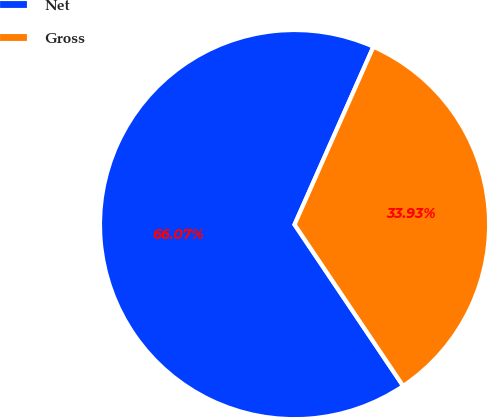Convert chart. <chart><loc_0><loc_0><loc_500><loc_500><pie_chart><fcel>Net<fcel>Gross<nl><fcel>66.07%<fcel>33.93%<nl></chart> 